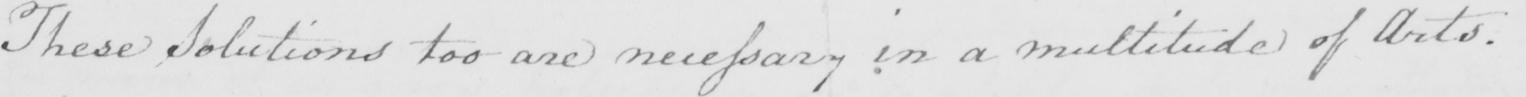What is written in this line of handwriting? These Solutions too are necessary in a multitude of Arts . 